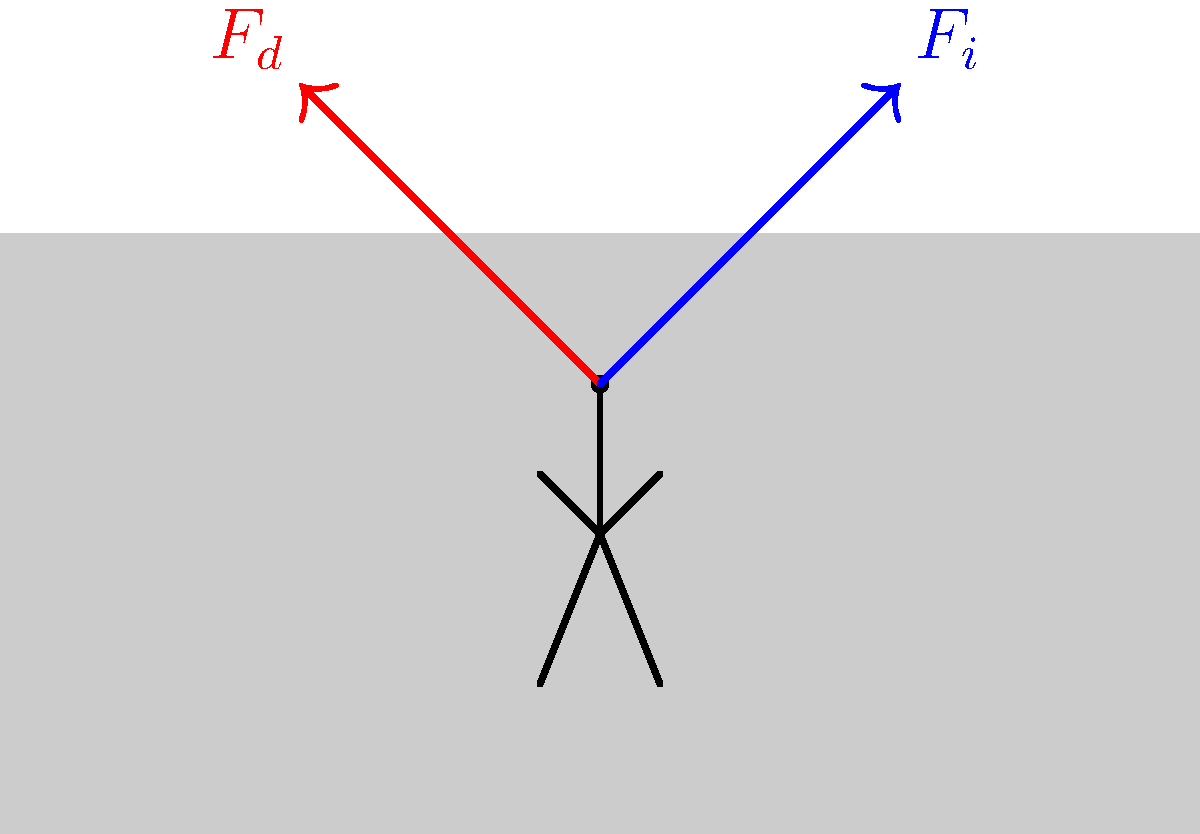In a frontal car crash, a driver experiences two primary forces: the deceleration force ($F_d$) and the impact force ($F_i$). If the driver's mass is 70 kg and the car decelerates from 100 km/h to 0 km/h in 0.1 seconds, what is the magnitude of the deceleration force ($F_d$) acting on the driver? To solve this problem, we'll follow these steps:

1. Convert the initial velocity from km/h to m/s:
   $v_i = 100 \text{ km/h} = 100 \times \frac{1000 \text{ m}}{3600 \text{ s}} = 27.78 \text{ m/s}$

2. Calculate the acceleration using the equation:
   $a = \frac{v_f - v_i}{t}$
   Where $v_f = 0 \text{ m/s}$, $v_i = 27.78 \text{ m/s}$, and $t = 0.1 \text{ s}$
   
   $a = \frac{0 - 27.78}{0.1} = -277.8 \text{ m/s}^2$

3. Use Newton's Second Law to calculate the force:
   $F = ma$
   Where $m = 70 \text{ kg}$ and $a = -277.8 \text{ m/s}^2$

   $F_d = 70 \times (-277.8) = -19,446 \text{ N}$

4. Take the absolute value of the force:
   $|F_d| = 19,446 \text{ N}$

Therefore, the magnitude of the deceleration force acting on the driver is 19,446 N.
Answer: 19,446 N 